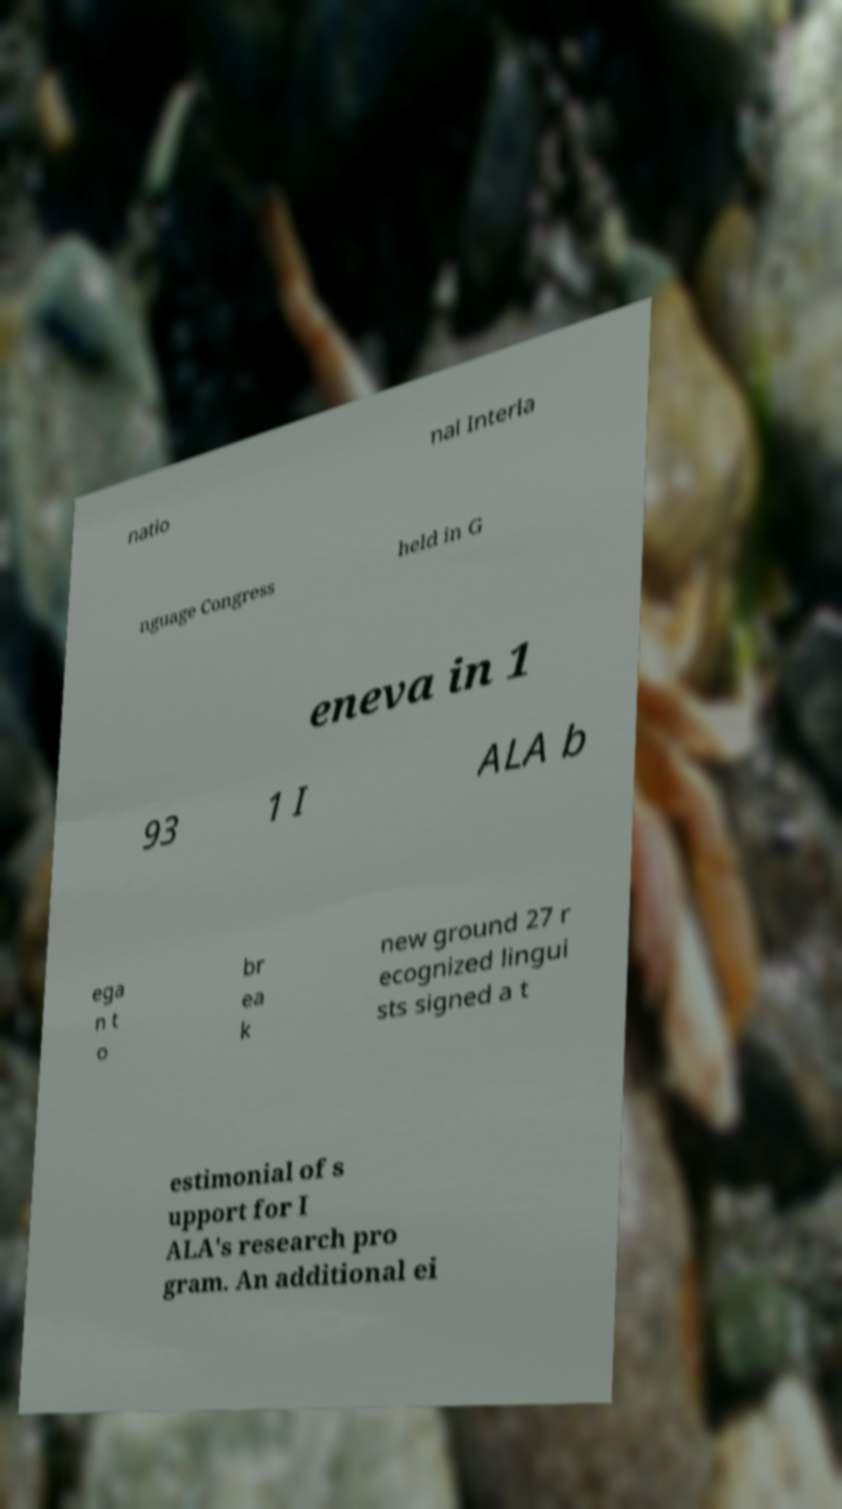Can you read and provide the text displayed in the image?This photo seems to have some interesting text. Can you extract and type it out for me? natio nal Interla nguage Congress held in G eneva in 1 93 1 I ALA b ega n t o br ea k new ground 27 r ecognized lingui sts signed a t estimonial of s upport for I ALA's research pro gram. An additional ei 